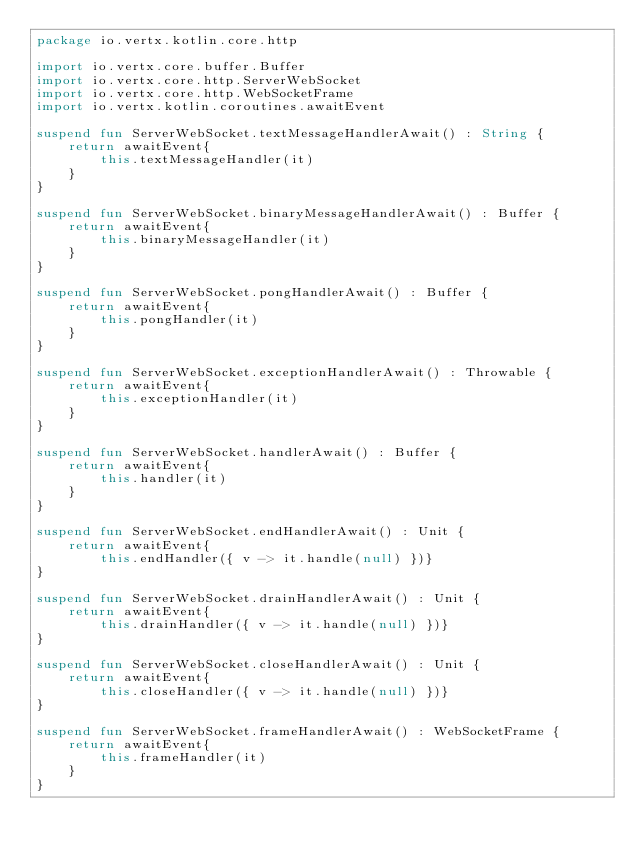Convert code to text. <code><loc_0><loc_0><loc_500><loc_500><_Kotlin_>package io.vertx.kotlin.core.http

import io.vertx.core.buffer.Buffer
import io.vertx.core.http.ServerWebSocket
import io.vertx.core.http.WebSocketFrame
import io.vertx.kotlin.coroutines.awaitEvent

suspend fun ServerWebSocket.textMessageHandlerAwait() : String {
    return awaitEvent{
        this.textMessageHandler(it)
    }
}

suspend fun ServerWebSocket.binaryMessageHandlerAwait() : Buffer {
    return awaitEvent{
        this.binaryMessageHandler(it)
    }
}

suspend fun ServerWebSocket.pongHandlerAwait() : Buffer {
    return awaitEvent{
        this.pongHandler(it)
    }
}

suspend fun ServerWebSocket.exceptionHandlerAwait() : Throwable {
    return awaitEvent{
        this.exceptionHandler(it)
    }
}

suspend fun ServerWebSocket.handlerAwait() : Buffer {
    return awaitEvent{
        this.handler(it)
    }
}

suspend fun ServerWebSocket.endHandlerAwait() : Unit {
    return awaitEvent{
        this.endHandler({ v -> it.handle(null) })}
}

suspend fun ServerWebSocket.drainHandlerAwait() : Unit {
    return awaitEvent{
        this.drainHandler({ v -> it.handle(null) })}
}

suspend fun ServerWebSocket.closeHandlerAwait() : Unit {
    return awaitEvent{
        this.closeHandler({ v -> it.handle(null) })}
}

suspend fun ServerWebSocket.frameHandlerAwait() : WebSocketFrame {
    return awaitEvent{
        this.frameHandler(it)
    }
}

</code> 